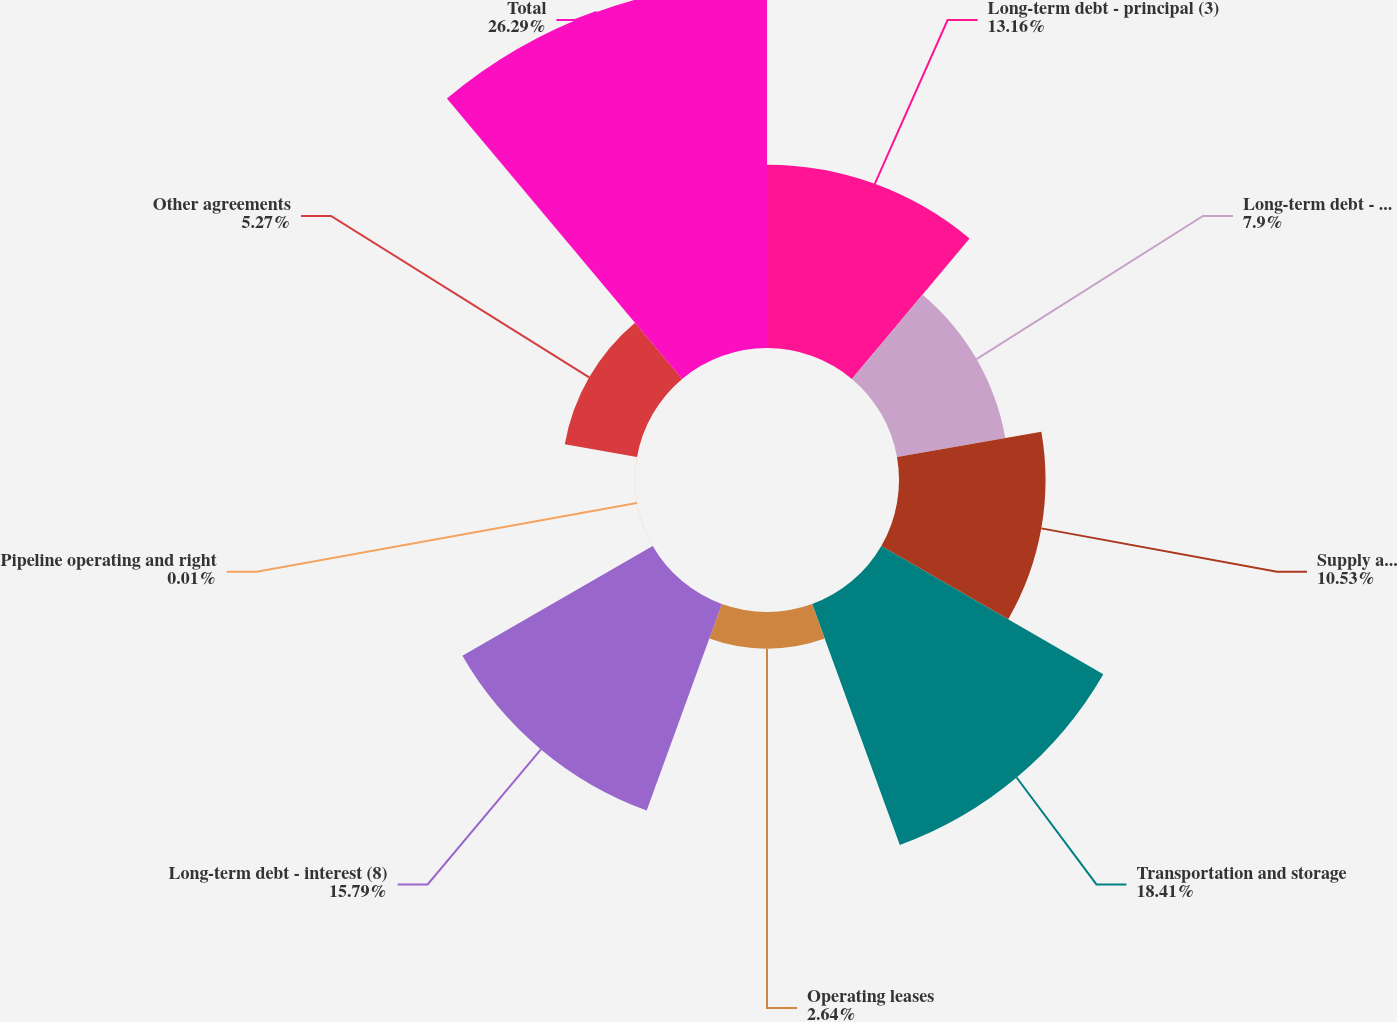Convert chart to OTSL. <chart><loc_0><loc_0><loc_500><loc_500><pie_chart><fcel>Long-term debt - principal (3)<fcel>Long-term debt - interest (4)<fcel>Supply agreements (5)<fcel>Transportation and storage<fcel>Operating leases<fcel>Long-term debt - interest (8)<fcel>Pipeline operating and right<fcel>Other agreements<fcel>Total<nl><fcel>13.16%<fcel>7.9%<fcel>10.53%<fcel>18.42%<fcel>2.64%<fcel>15.79%<fcel>0.01%<fcel>5.27%<fcel>26.3%<nl></chart> 